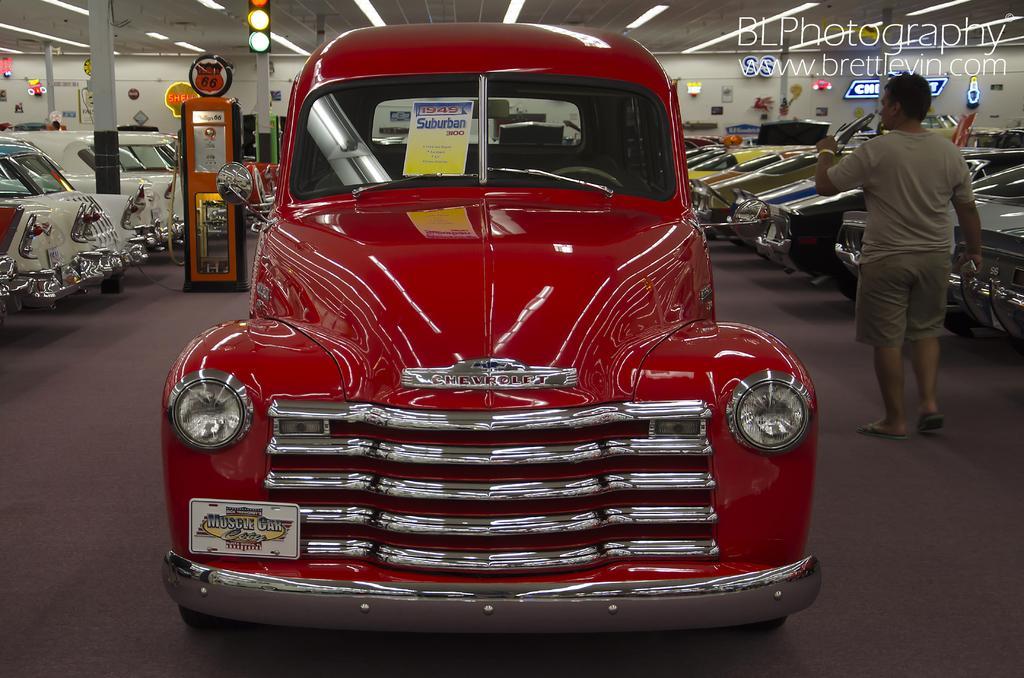Describe this image in one or two sentences. In the center of the image there is a red car. On both right and left side of the image there are cars. On the right side of the image there is a person walking on the mat. On the left side of the image there is machine. In the background of the image there are traffic lights. There are some objects on the wall. On top of the image there are lights. There is some text on the top right side of the image. 